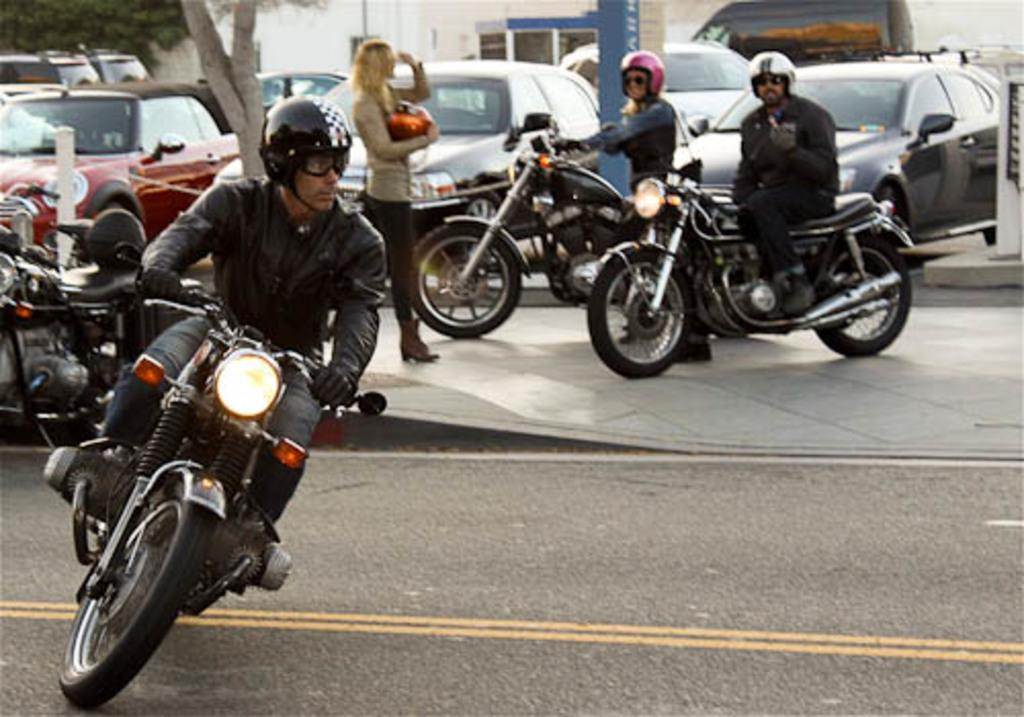What types of transportation are present in the image? There are vehicles in the image, and some of them are on bikes. What can be seen in the distance in the image? There are buildings and trees in the background of the image. What is at the bottom of the image? There is a road at the bottom of the image. What type of crime is being committed in the image? There is no indication of any crime being committed in the image. Can you tell me where the hospital is located in the image? There is no hospital present in the image. 